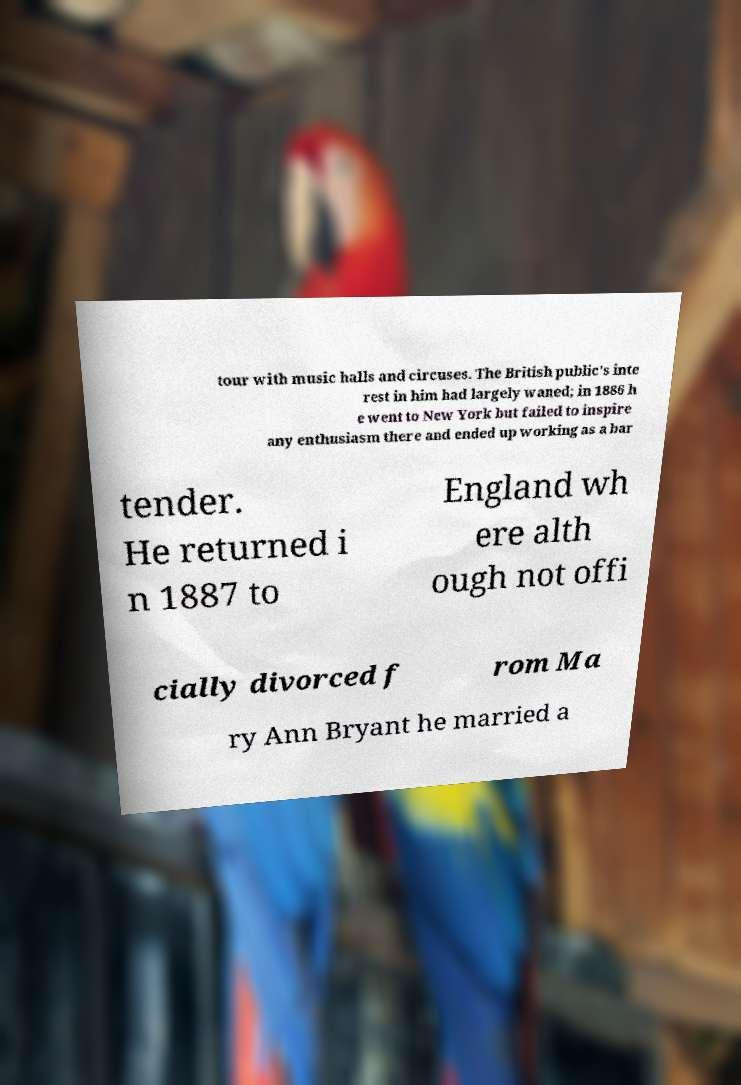There's text embedded in this image that I need extracted. Can you transcribe it verbatim? tour with music halls and circuses. The British public's inte rest in him had largely waned; in 1886 h e went to New York but failed to inspire any enthusiasm there and ended up working as a bar tender. He returned i n 1887 to England wh ere alth ough not offi cially divorced f rom Ma ry Ann Bryant he married a 